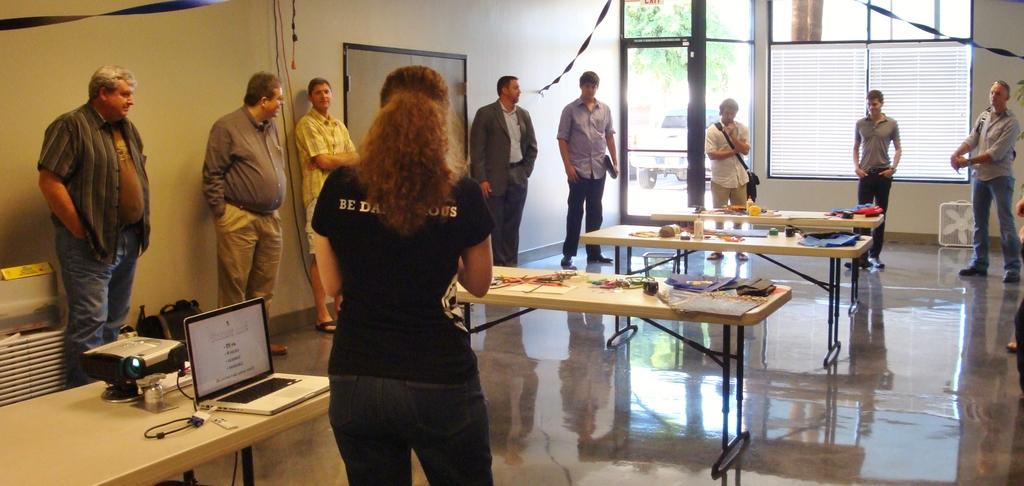Describe this image in one or two sentences. In the image we can see there are people who are standing and on the table there are bottles, cloth and in other there is laptop and a projector. 